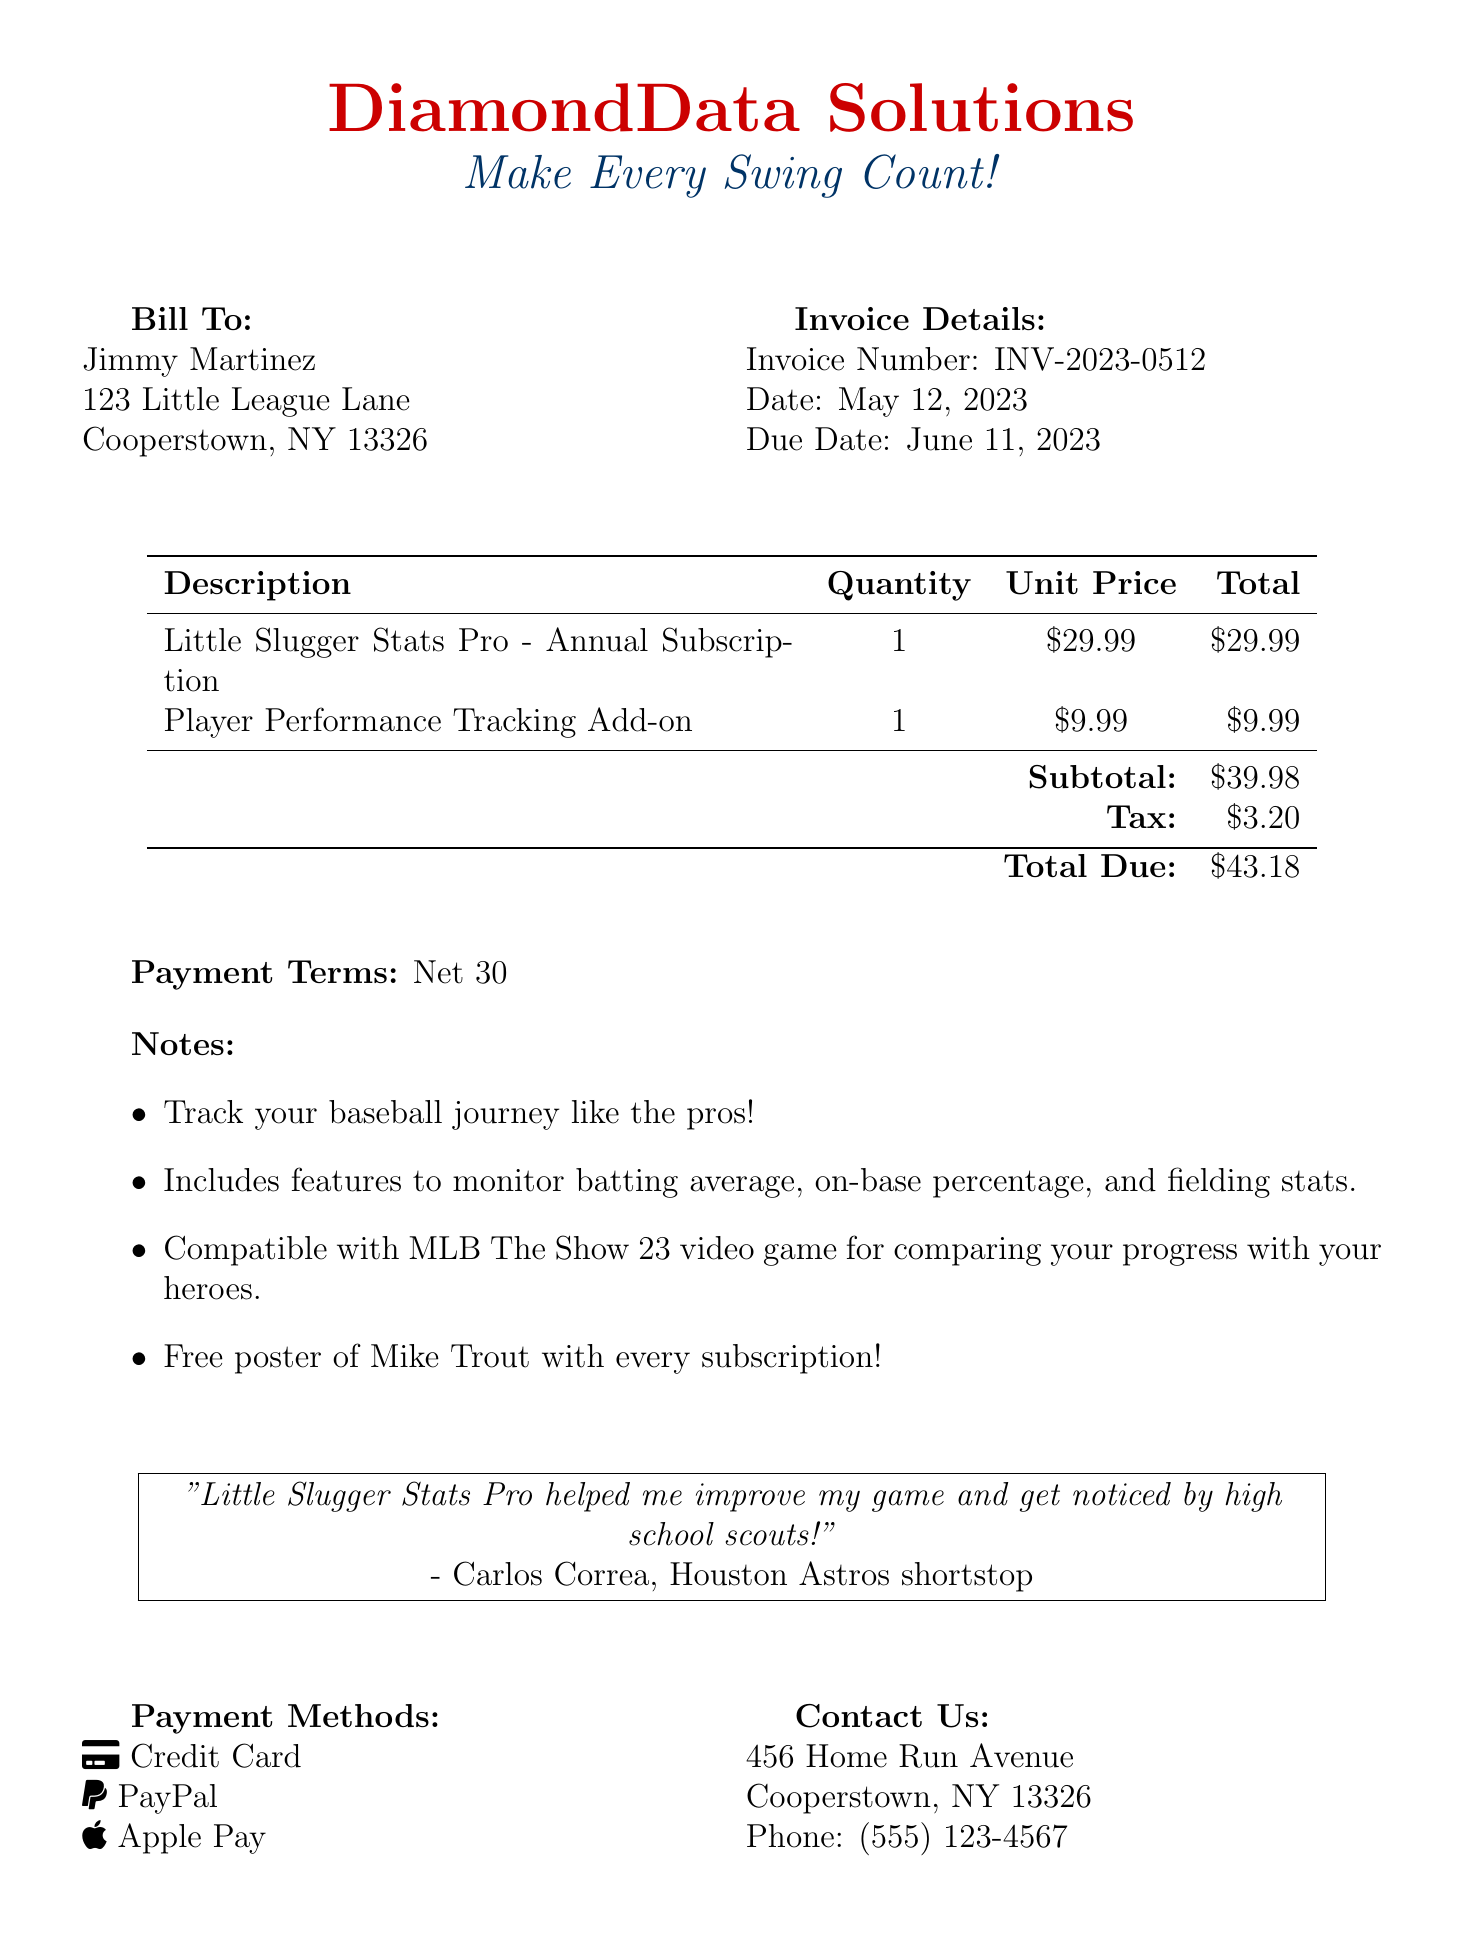What is the invoice number? The invoice number is identified in the document as a unique reference for tracking purposes.
Answer: INV-2023-0512 What is the total amount due? The total amount due is calculated by adding the subtotal and tax specified in the document.
Answer: $43.18 Who is the invoice billed to? The document clearly states the name and address of the individual being billed, which is important for billing records.
Answer: Jimmy Martinez What is included in the subscription? The document lists specific features of the subscription, useful for potential customers to understand what they will get.
Answer: Track your baseball journey like the pros! What is the due date for payment? The due date is mentioned in the document for clarity on when the payment is expected.
Answer: June 11, 2023 What are the payment methods? The document outlines acceptable methods for payment, giving options to the customer.
Answer: Credit Card, PayPal, Apple Pay What is the subtotal before tax? The subtotal is provided before the tax is added, helping to understand the base cost of the items.
Answer: $39.98 Who provided a testimonial for the software? The testimonial gives credibility to the product, and noting who gave it can influence purchasing decisions.
Answer: Carlos Correa What is the purpose of the add-on feature? Understanding the add-on feature's purpose helps a customer see the additional benefits of the service.
Answer: Player Performance Tracking 